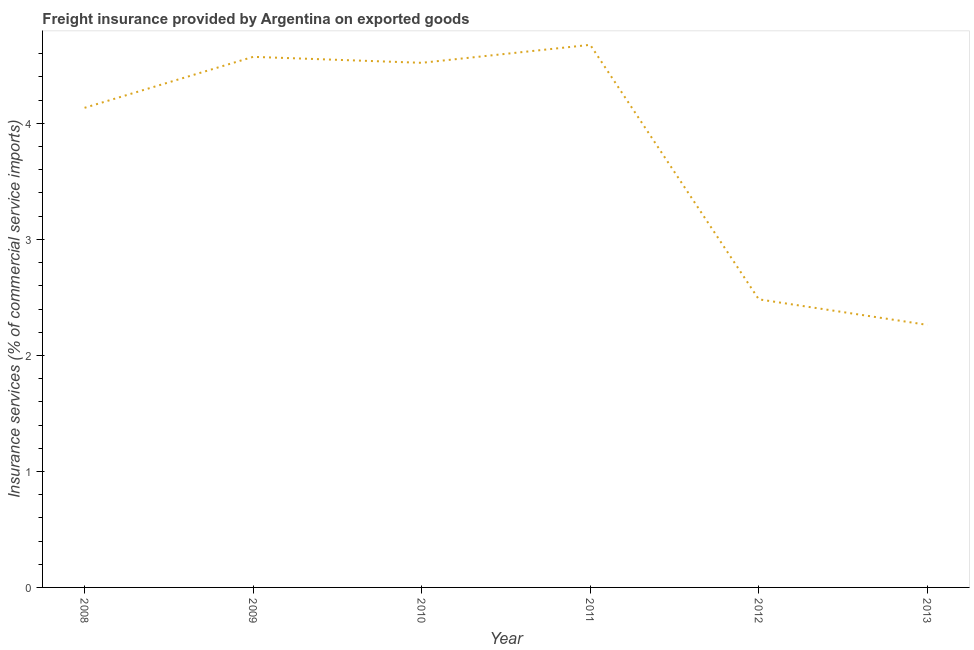What is the freight insurance in 2008?
Offer a terse response. 4.13. Across all years, what is the maximum freight insurance?
Keep it short and to the point. 4.68. Across all years, what is the minimum freight insurance?
Provide a succinct answer. 2.26. In which year was the freight insurance maximum?
Offer a terse response. 2011. What is the sum of the freight insurance?
Offer a very short reply. 22.65. What is the difference between the freight insurance in 2008 and 2013?
Give a very brief answer. 1.87. What is the average freight insurance per year?
Offer a terse response. 3.78. What is the median freight insurance?
Ensure brevity in your answer.  4.33. What is the ratio of the freight insurance in 2008 to that in 2012?
Ensure brevity in your answer.  1.66. What is the difference between the highest and the second highest freight insurance?
Ensure brevity in your answer.  0.1. What is the difference between the highest and the lowest freight insurance?
Make the answer very short. 2.41. Does the freight insurance monotonically increase over the years?
Your response must be concise. No. How many years are there in the graph?
Your answer should be very brief. 6. What is the difference between two consecutive major ticks on the Y-axis?
Keep it short and to the point. 1. Does the graph contain grids?
Keep it short and to the point. No. What is the title of the graph?
Keep it short and to the point. Freight insurance provided by Argentina on exported goods . What is the label or title of the Y-axis?
Your response must be concise. Insurance services (% of commercial service imports). What is the Insurance services (% of commercial service imports) of 2008?
Keep it short and to the point. 4.13. What is the Insurance services (% of commercial service imports) in 2009?
Make the answer very short. 4.57. What is the Insurance services (% of commercial service imports) of 2010?
Your response must be concise. 4.52. What is the Insurance services (% of commercial service imports) in 2011?
Offer a very short reply. 4.68. What is the Insurance services (% of commercial service imports) in 2012?
Ensure brevity in your answer.  2.48. What is the Insurance services (% of commercial service imports) of 2013?
Your response must be concise. 2.26. What is the difference between the Insurance services (% of commercial service imports) in 2008 and 2009?
Keep it short and to the point. -0.44. What is the difference between the Insurance services (% of commercial service imports) in 2008 and 2010?
Your answer should be compact. -0.39. What is the difference between the Insurance services (% of commercial service imports) in 2008 and 2011?
Your answer should be compact. -0.54. What is the difference between the Insurance services (% of commercial service imports) in 2008 and 2012?
Your response must be concise. 1.65. What is the difference between the Insurance services (% of commercial service imports) in 2008 and 2013?
Your response must be concise. 1.87. What is the difference between the Insurance services (% of commercial service imports) in 2009 and 2010?
Your answer should be compact. 0.05. What is the difference between the Insurance services (% of commercial service imports) in 2009 and 2011?
Make the answer very short. -0.1. What is the difference between the Insurance services (% of commercial service imports) in 2009 and 2012?
Your response must be concise. 2.09. What is the difference between the Insurance services (% of commercial service imports) in 2009 and 2013?
Ensure brevity in your answer.  2.31. What is the difference between the Insurance services (% of commercial service imports) in 2010 and 2011?
Offer a very short reply. -0.16. What is the difference between the Insurance services (% of commercial service imports) in 2010 and 2012?
Keep it short and to the point. 2.04. What is the difference between the Insurance services (% of commercial service imports) in 2010 and 2013?
Offer a very short reply. 2.26. What is the difference between the Insurance services (% of commercial service imports) in 2011 and 2012?
Your response must be concise. 2.19. What is the difference between the Insurance services (% of commercial service imports) in 2011 and 2013?
Make the answer very short. 2.41. What is the difference between the Insurance services (% of commercial service imports) in 2012 and 2013?
Give a very brief answer. 0.22. What is the ratio of the Insurance services (% of commercial service imports) in 2008 to that in 2009?
Make the answer very short. 0.9. What is the ratio of the Insurance services (% of commercial service imports) in 2008 to that in 2010?
Make the answer very short. 0.91. What is the ratio of the Insurance services (% of commercial service imports) in 2008 to that in 2011?
Provide a succinct answer. 0.88. What is the ratio of the Insurance services (% of commercial service imports) in 2008 to that in 2012?
Provide a succinct answer. 1.67. What is the ratio of the Insurance services (% of commercial service imports) in 2008 to that in 2013?
Your answer should be very brief. 1.83. What is the ratio of the Insurance services (% of commercial service imports) in 2009 to that in 2011?
Give a very brief answer. 0.98. What is the ratio of the Insurance services (% of commercial service imports) in 2009 to that in 2012?
Your answer should be very brief. 1.84. What is the ratio of the Insurance services (% of commercial service imports) in 2009 to that in 2013?
Your answer should be compact. 2.02. What is the ratio of the Insurance services (% of commercial service imports) in 2010 to that in 2011?
Give a very brief answer. 0.97. What is the ratio of the Insurance services (% of commercial service imports) in 2010 to that in 2012?
Provide a short and direct response. 1.82. What is the ratio of the Insurance services (% of commercial service imports) in 2010 to that in 2013?
Your answer should be compact. 2. What is the ratio of the Insurance services (% of commercial service imports) in 2011 to that in 2012?
Your response must be concise. 1.88. What is the ratio of the Insurance services (% of commercial service imports) in 2011 to that in 2013?
Your answer should be compact. 2.07. What is the ratio of the Insurance services (% of commercial service imports) in 2012 to that in 2013?
Your response must be concise. 1.1. 